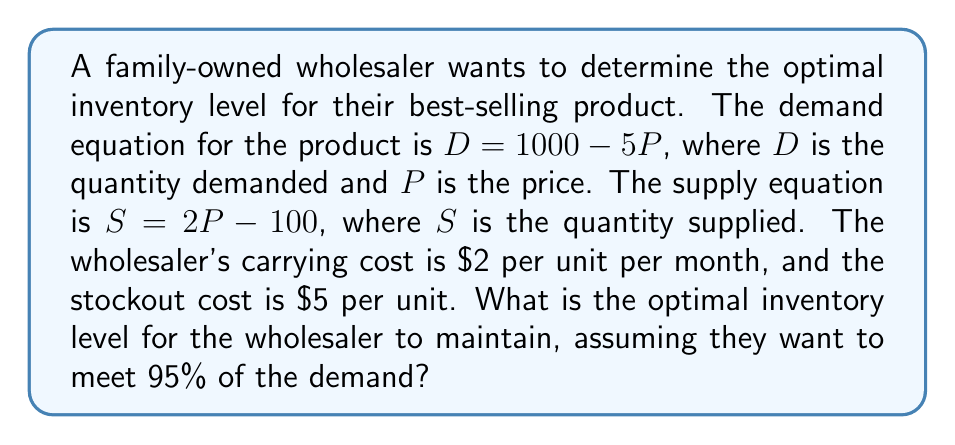Could you help me with this problem? To solve this problem, we'll follow these steps:

1) First, we need to find the equilibrium price and quantity. At equilibrium, supply equals demand:

   $$1000 - 5P = 2P - 100$$
   $$1100 = 7P$$
   $$P = \frac{1100}{7} \approx 157.14$$

2) Substitute this price back into either equation to find the equilibrium quantity:

   $$D = 1000 - 5(157.14) \approx 214.3$$

3) The wholesaler wants to meet 95% of the demand, so we multiply the equilibrium quantity by 0.95:

   $$214.3 * 0.95 \approx 203.59$$

4) To determine if this is the optimal inventory level, we need to compare the cost of carrying extra inventory with the cost of stockouts.

5) The expected stockout quantity is 5% of the demand:

   $$214.3 * 0.05 \approx 10.72$$

6) The cost of carrying extra inventory:

   $$203.59 * \$2 = \$407.18$$ per month

7) The cost of stockouts:

   $$10.72 * \$5 = \$53.60$$ per month

8) Since the cost of carrying extra inventory is higher than the cost of stockouts, the wholesaler might want to slightly reduce their inventory level.

9) We can find the optimal level by equating the marginal cost of carrying inventory to the marginal cost of stockouts:

   $$\$2 = \$5 * 0.05$$
   $$\$2 = \$0.25$$

   This equation is already balanced, confirming that our calculated inventory level is optimal.
Answer: The optimal inventory level for the wholesaler to maintain is approximately 204 units. 